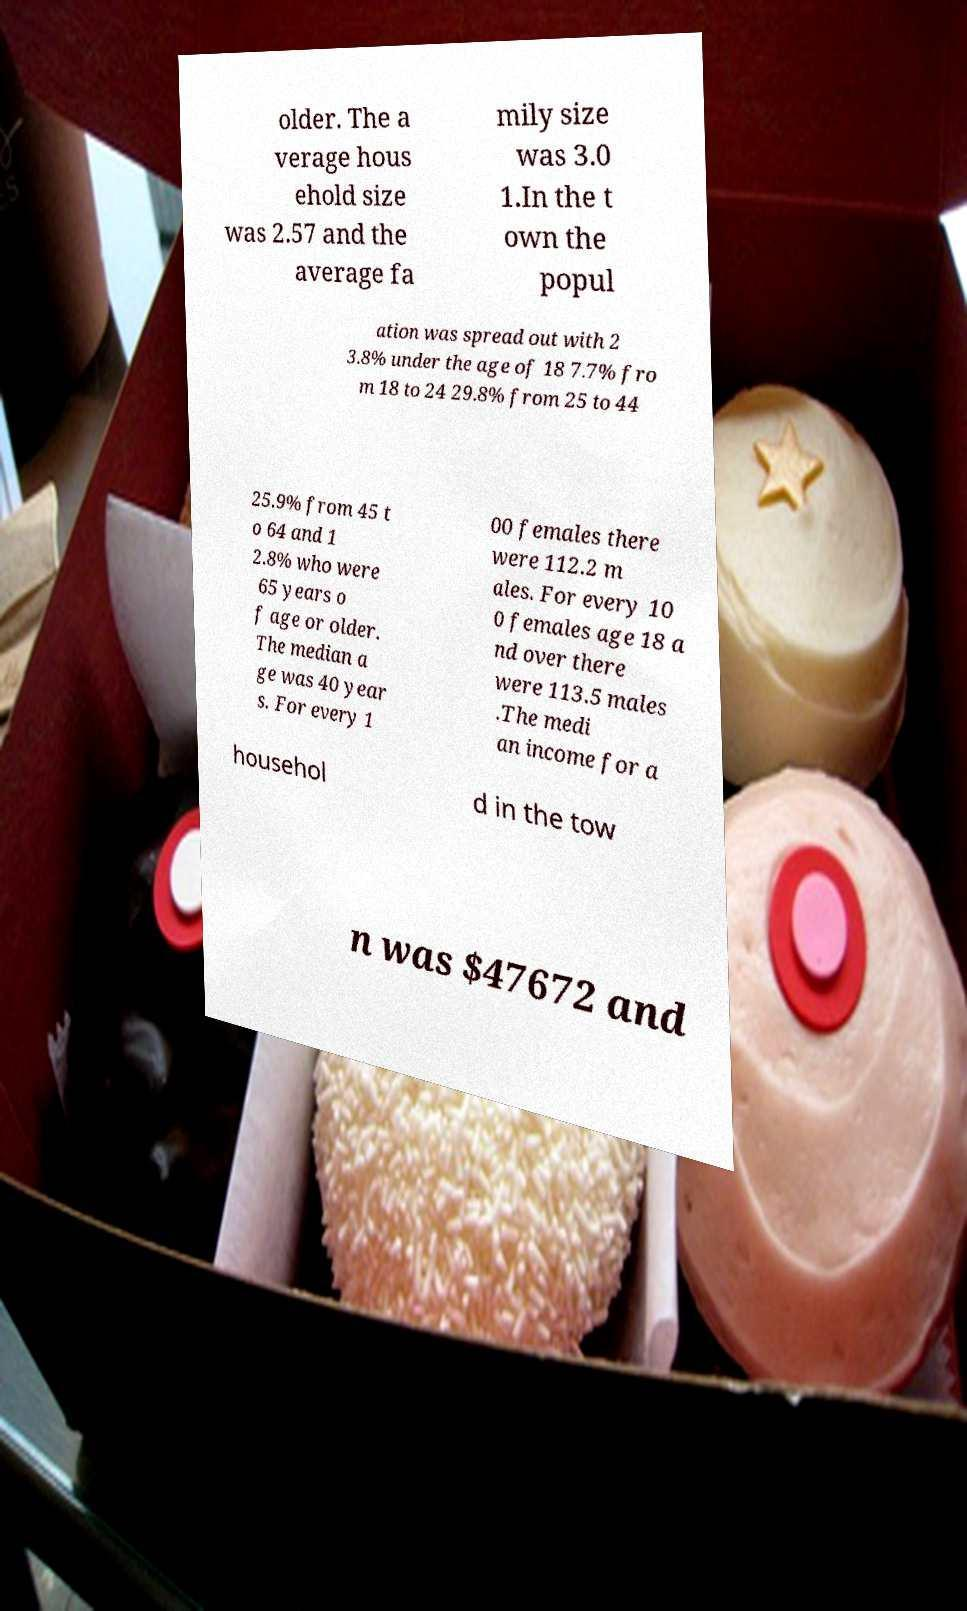Please read and relay the text visible in this image. What does it say? older. The a verage hous ehold size was 2.57 and the average fa mily size was 3.0 1.In the t own the popul ation was spread out with 2 3.8% under the age of 18 7.7% fro m 18 to 24 29.8% from 25 to 44 25.9% from 45 t o 64 and 1 2.8% who were 65 years o f age or older. The median a ge was 40 year s. For every 1 00 females there were 112.2 m ales. For every 10 0 females age 18 a nd over there were 113.5 males .The medi an income for a househol d in the tow n was $47672 and 